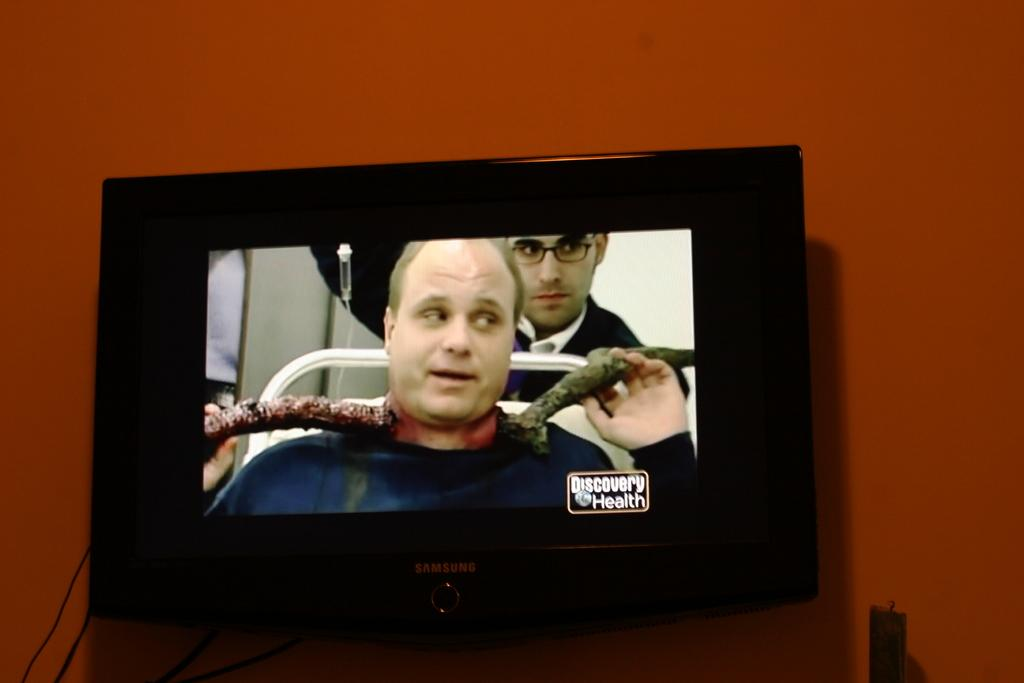<image>
Relay a brief, clear account of the picture shown. The tv is showing a program with the words discovery health on the bottom right. 